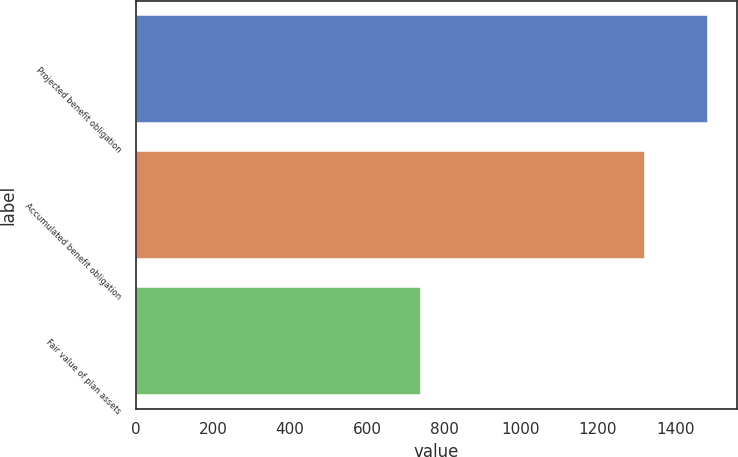Convert chart to OTSL. <chart><loc_0><loc_0><loc_500><loc_500><bar_chart><fcel>Projected benefit obligation<fcel>Accumulated benefit obligation<fcel>Fair value of plan assets<nl><fcel>1486<fcel>1323<fcel>740<nl></chart> 